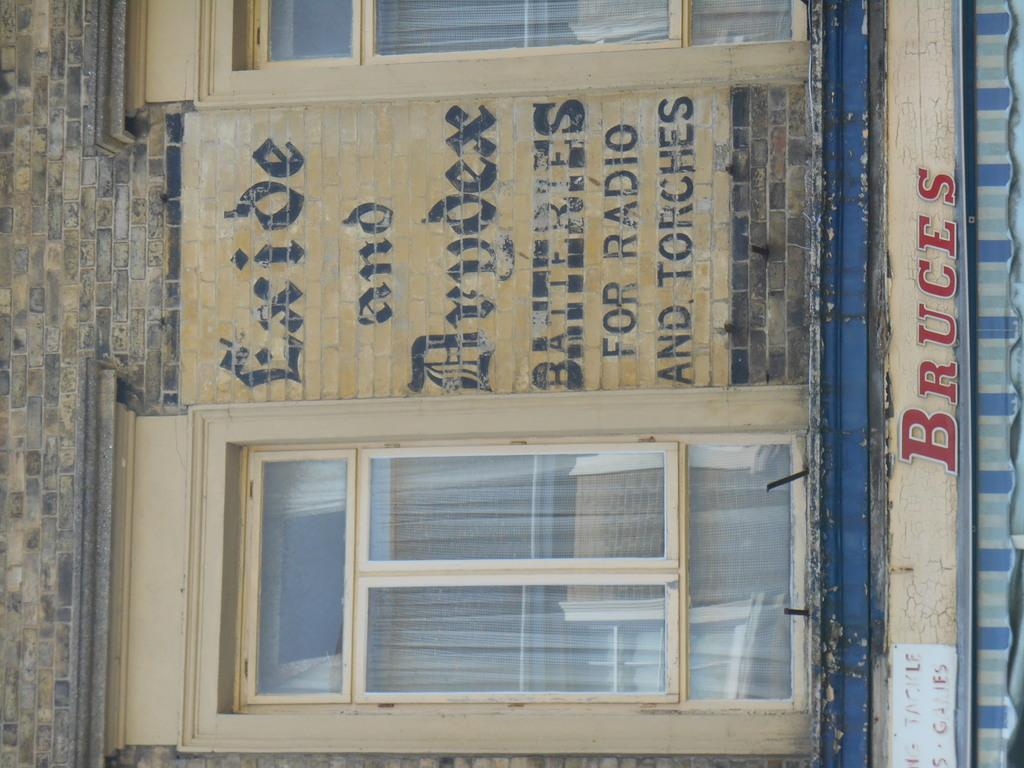What is a prominent feature in the image? There is a wall in the image. What is on the wall? Something is written on the wall. What can be seen near the wall? There are windows with glass in the image. What is near the windows? There is text visible near the windows. What type of structure is present in the image? There is a tent in the image. How many eyes can be seen on the tent in the image? There are no eyes visible on the tent in the image. 